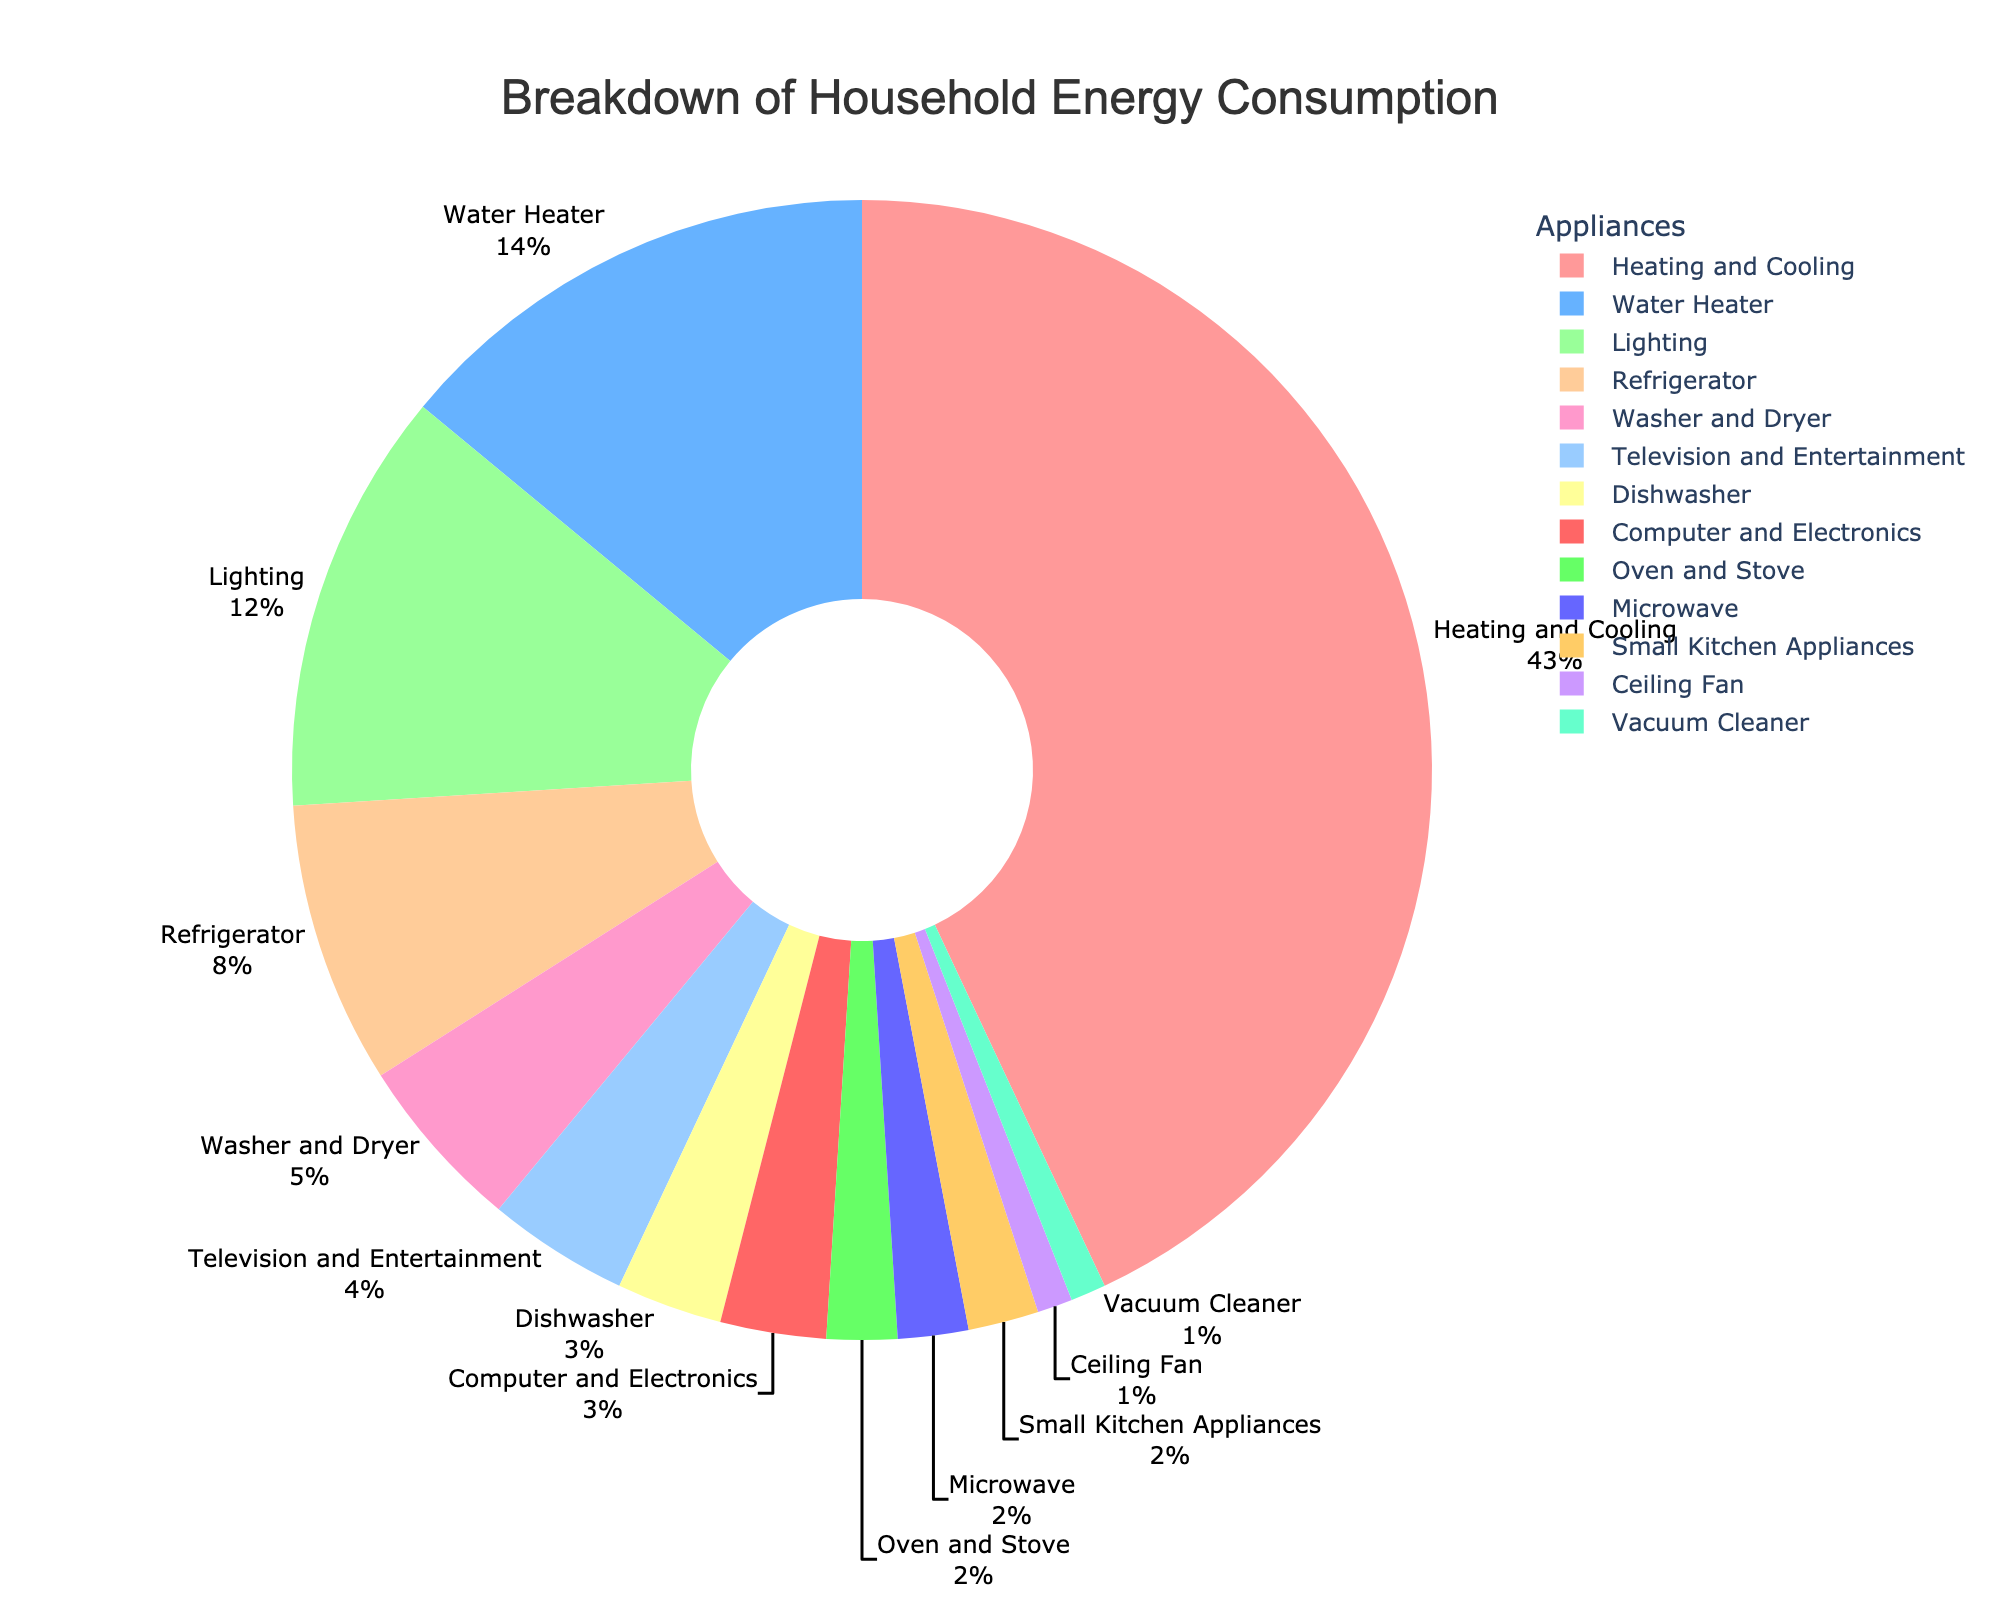Which appliance category uses the highest percentage of energy? The pie chart shows that "Heating and Cooling" uses the highest percentage of energy, accounting for 43% of the total household energy consumption.
Answer: Heating and Cooling What is the combined percentage of energy consumption for the 'Washer and Dryer' and 'Television and Entertainment' categories? The pie chart indicates that the 'Washer and Dryer' category uses 5% of energy and the 'Television and Entertainment' category uses 4%. Adding these together, 5% + 4% = 9%.
Answer: 9% Is the percentage of energy consumed by the 'Refrigerator' greater than or less than the 'Water Heater'? The pie chart shows that the 'Refrigerator' uses 8% of energy while the 'Water Heater' uses 14%. Hence, the refrigerator uses less energy than the water heater.
Answer: Less than What is the difference in percentage between the highest and lowest energy-consuming appliance categories? The highest energy-consuming category is 'Heating and Cooling' at 43%, and the lowest are 'Ceiling Fan' and 'Vacuum Cleaner' at 1% each. The difference is 43% - 1% = 42%.
Answer: 42% What is the combined energy consumption of all kitchen appliances (Refrigerator, Dishwasher, Oven and Stove, Microwave, Small Kitchen Appliances)? The percentages for the kitchen appliances are Refrigerator (8%), Dishwasher (3%), Oven and Stove (2%), Microwave (2%), and Small Kitchen Appliances (2%). Adding these together, 8% + 3% + 2% + 2% + 2% = 17%.
Answer: 17% Which is the lowest energy-consuming appliance? The pie chart shows that the 'Ceiling Fan' and 'Vacuum Cleaner' each use 1% of energy, making them the lowest energy-consuming appliances.
Answer: Ceiling Fan, Vacuum Cleaner What percentage of energy consumption is attributed to lighting? According to the pie chart, lighting accounts for 12% of the total household energy consumption.
Answer: 12% How much more energy does 'Heating and Cooling' consume compared to 'Lighting'? The pie chart shows that 'Heating and Cooling' consumes 43% of energy, while 'Lighting' consumes 12%. The difference is 43% - 12% = 31%.
Answer: 31% Among 'Microwave', 'Small Kitchen Appliances', and 'Computer and Electronics', which has the highest energy consumption and what is its value? The pie chart indicates that 'Microwave' and 'Small Kitchen Appliances' each consume 2%, while 'Computer and Electronics' consumes 3%. The highest is 'Computer and Electronics' with 3%.
Answer: Computer and Electronics, 3% If you combine the energy usage of 'Computer and Electronics', 'Ceiling Fan', and 'Vacuum Cleaner', does it exceed the energy usage of the 'Water Heater'? Combining 'Computer and Electronics' (3%), 'Ceiling Fan' (1%), and 'Vacuum Cleaner' (1%) results in 3% + 1% + 1% = 5%. The 'Water Heater' uses 14%, so 5% does not exceed 14%.
Answer: No 